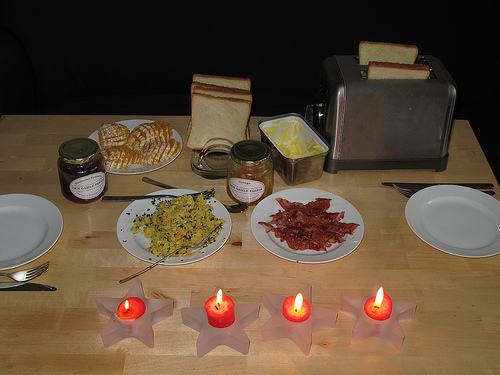<image>
Is the candle on the star? Yes. Looking at the image, I can see the candle is positioned on top of the star, with the star providing support. Is the food on the plate? No. The food is not positioned on the plate. They may be near each other, but the food is not supported by or resting on top of the plate. Where is the food in relation to the plate? Is it in the plate? No. The food is not contained within the plate. These objects have a different spatial relationship. 